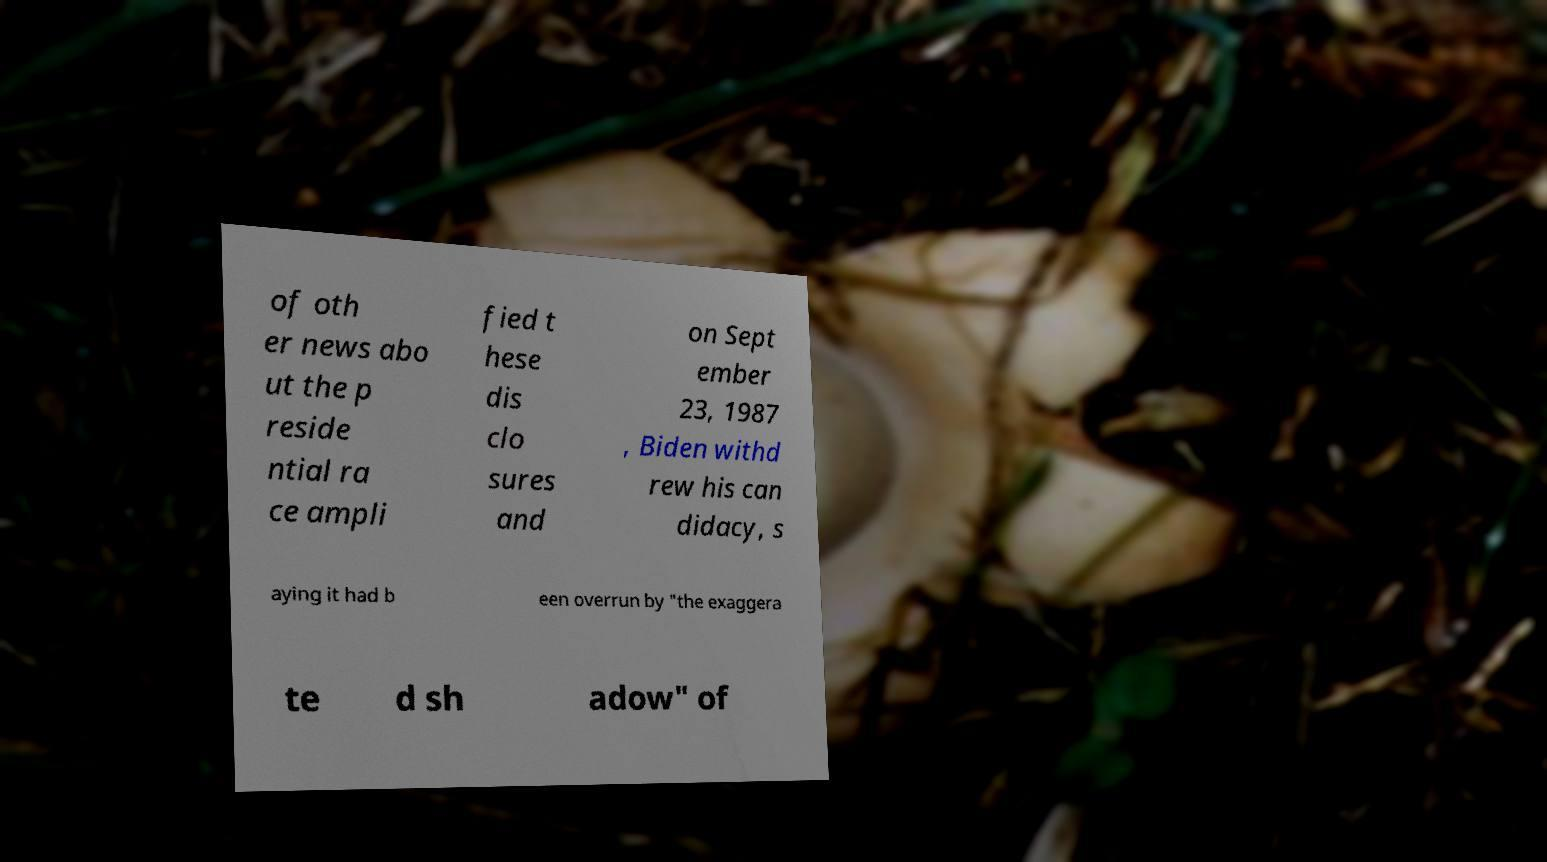Please read and relay the text visible in this image. What does it say? of oth er news abo ut the p reside ntial ra ce ampli fied t hese dis clo sures and on Sept ember 23, 1987 , Biden withd rew his can didacy, s aying it had b een overrun by "the exaggera te d sh adow" of 